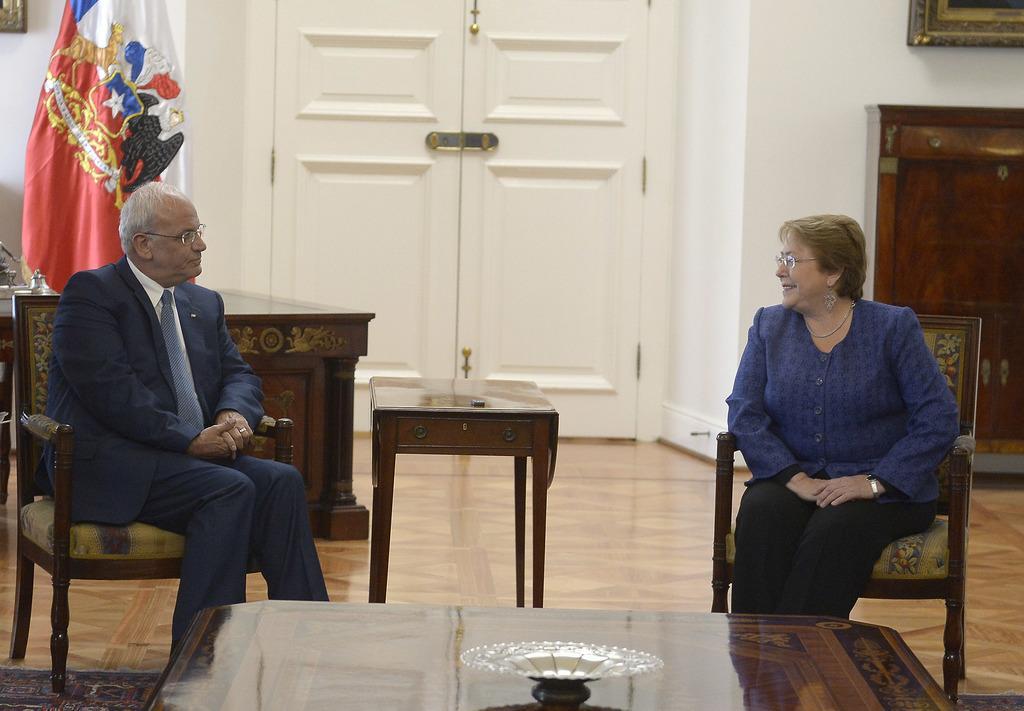Please provide a concise description of this image. 2 people are sitting on the chair. in front of them there is a table. behind them there is a white door. at the left corner there is a flag. 